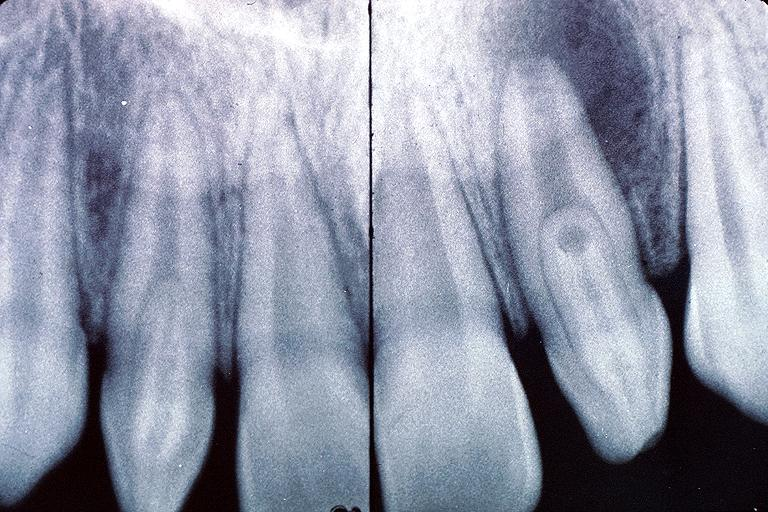does natural color show dens invaginatus?
Answer the question using a single word or phrase. No 